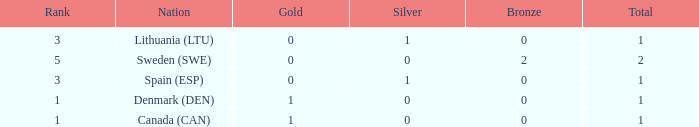What is the rank when there is 0 gold, the total is more than 1, and silver is more than 0? None. 